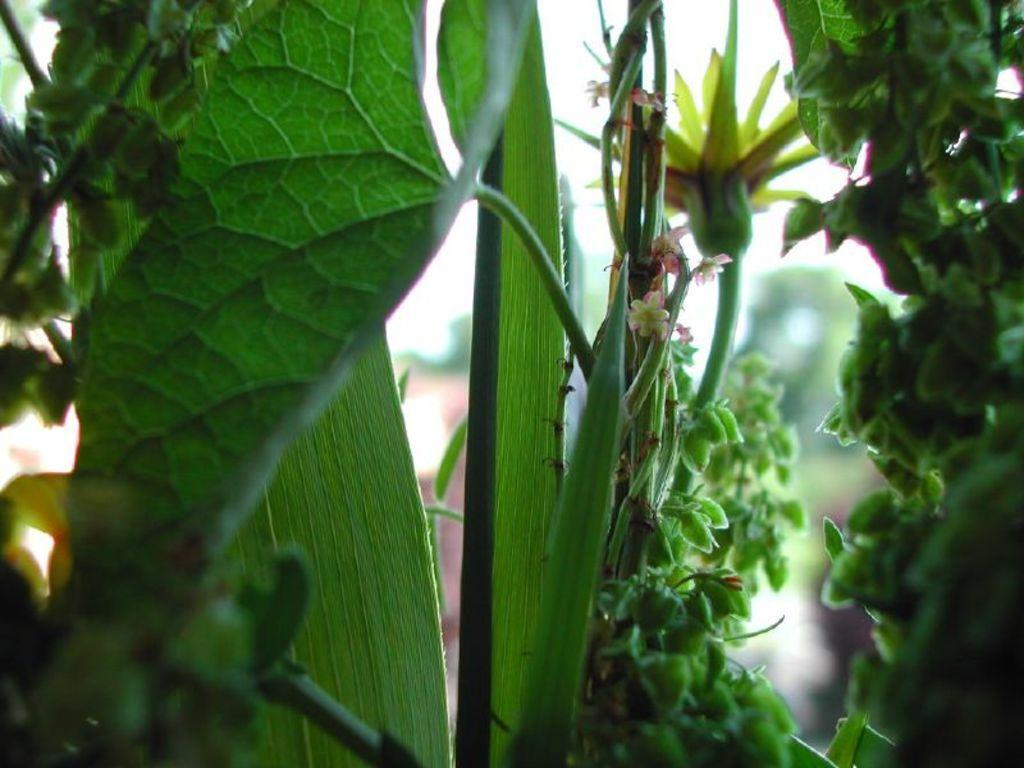What type of living organisms can be seen in the image? Plants and a flower can be seen in the image. Can you describe the background of the image? The background of the image is blurry. What type of substance is being agreed upon by the string in the image? There is no substance or string present in the image. What type of agreement is being made by the plants in the image? The plants in the image are not making any agreements; they are simply growing. 